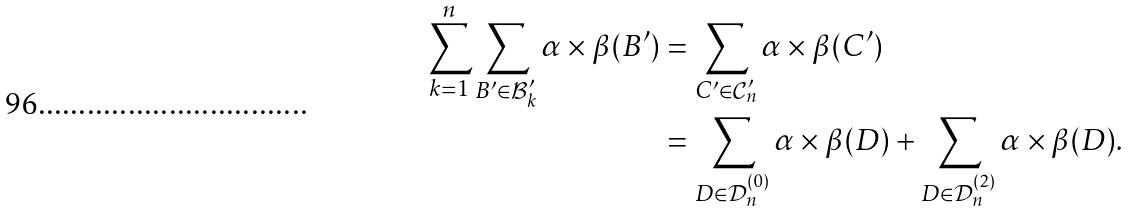Convert formula to latex. <formula><loc_0><loc_0><loc_500><loc_500>\sum _ { k = 1 } ^ { n } \sum _ { B ^ { \prime } \in \mathcal { B } _ { k } ^ { \prime } } \alpha \times \beta ( B ^ { \prime } ) & = \sum _ { C ^ { \prime } \in \mathcal { C } _ { n } ^ { \prime } } \alpha \times \beta ( C ^ { \prime } ) \\ & = \sum _ { D \in \mathcal { D } _ { n } ^ { ( 0 ) } } \alpha \times \beta ( D ) + \sum _ { D \in \mathcal { D } _ { n } ^ { ( 2 ) } } \alpha \times \beta ( D ) .</formula> 